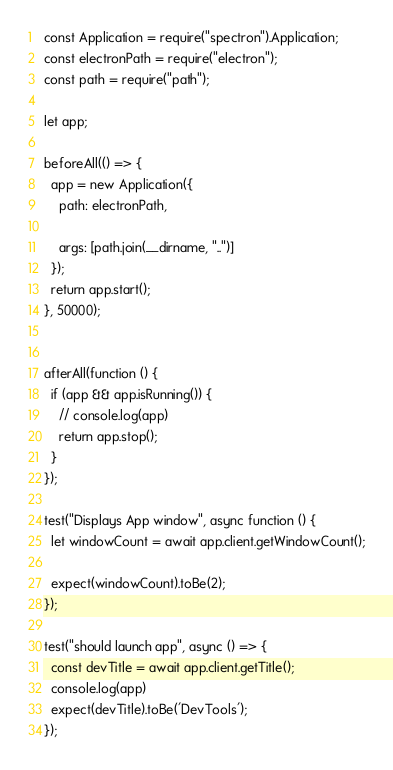<code> <loc_0><loc_0><loc_500><loc_500><_JavaScript_>const Application = require("spectron").Application;
const electronPath = require("electron");
const path = require("path");

let app;

beforeAll(() => {
  app = new Application({
    path: electronPath,

    args: [path.join(__dirname, "..")]
  });
  return app.start();
}, 50000);


afterAll(function () {
  if (app && app.isRunning()) {
    // console.log(app)
    return app.stop();
  }
});

test("Displays App window", async function () {
  let windowCount = await app.client.getWindowCount();

  expect(windowCount).toBe(2);
});

test("should launch app", async () => {
  const devTitle = await app.client.getTitle();
  console.log(app)
  expect(devTitle).toBe('DevTools'); 
});</code> 